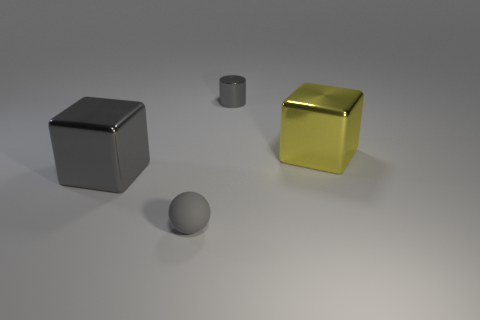Add 3 small purple matte spheres. How many objects exist? 7 Subtract all balls. How many objects are left? 3 Subtract all small cyan matte things. Subtract all metallic objects. How many objects are left? 1 Add 4 matte things. How many matte things are left? 5 Add 4 cyan spheres. How many cyan spheres exist? 4 Subtract 1 gray cubes. How many objects are left? 3 